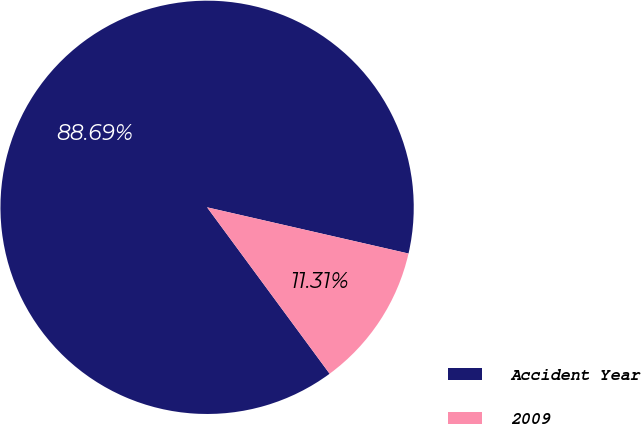Convert chart. <chart><loc_0><loc_0><loc_500><loc_500><pie_chart><fcel>Accident Year<fcel>2009<nl><fcel>88.69%<fcel>11.31%<nl></chart> 